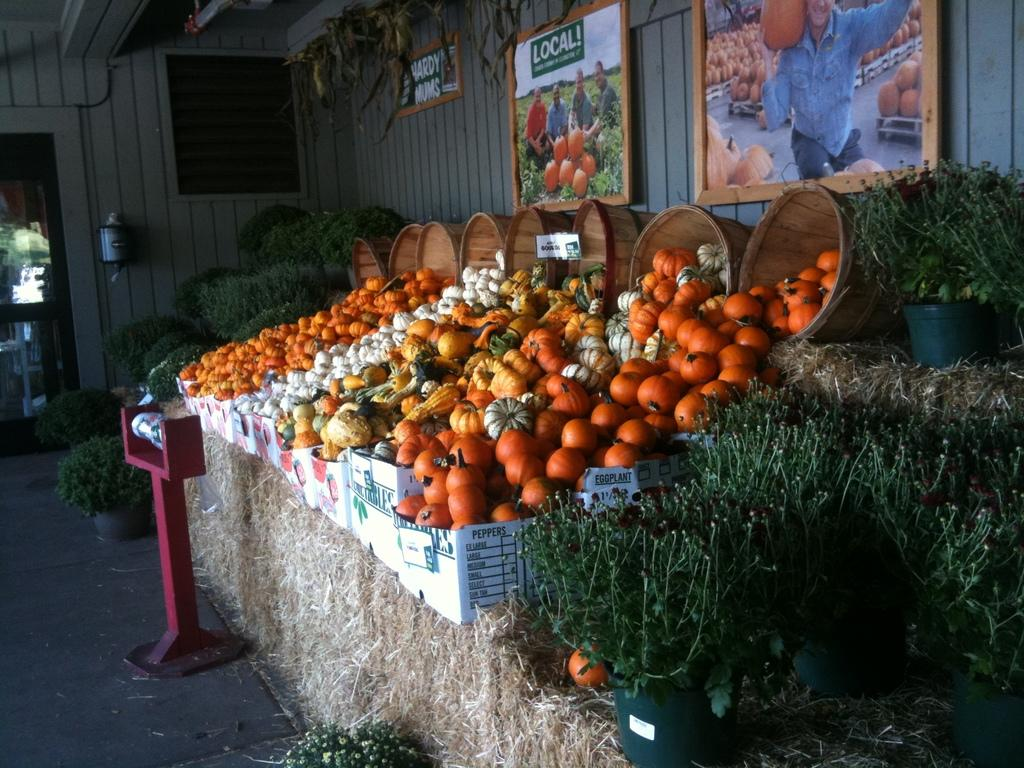What type of structure can be seen in the image? There is a wall in the image. What decorations are hanging on the wall? There are banners in the image. What type of vegetation is present in the image? Dry grass is present in the image. What type of containers can be seen in the image? There are baskets in the image. What type of food items are visible in the image? Different types of vegetables are visible in the image. What type of cake is being served with a spoon in the image? There is no cake or spoon present in the image; it features a wall, banners, dry grass, baskets, and vegetables. What type of cow can be seen grazing on the dry grass in the image? There is no cow present in the image; it only features dry grass, baskets, and vegetables. 